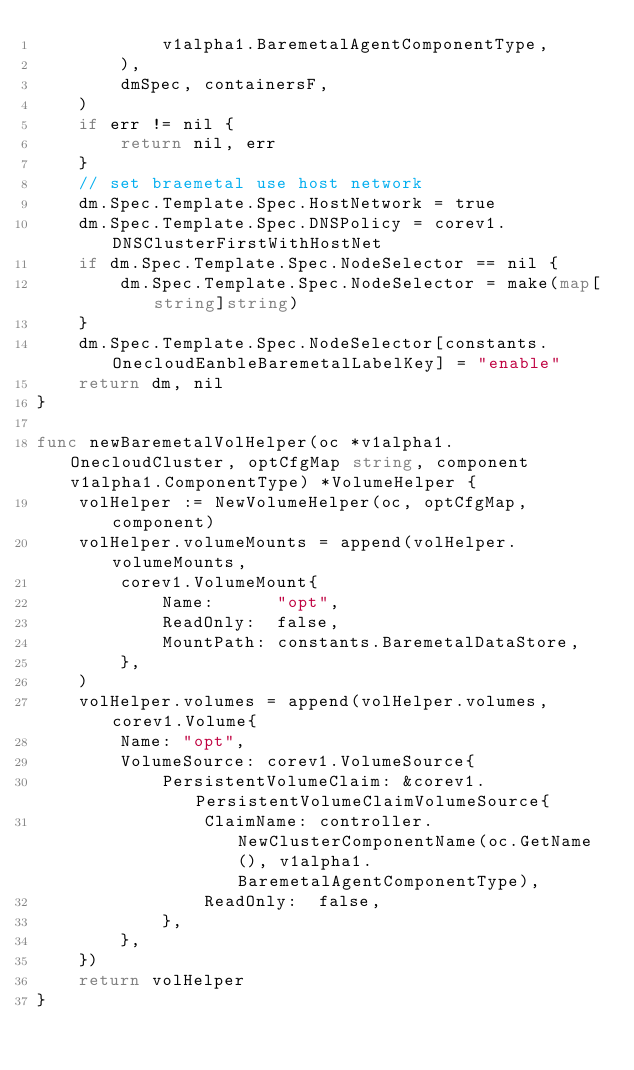<code> <loc_0><loc_0><loc_500><loc_500><_Go_>			v1alpha1.BaremetalAgentComponentType,
		),
		dmSpec, containersF,
	)
	if err != nil {
		return nil, err
	}
	// set braemetal use host network
	dm.Spec.Template.Spec.HostNetwork = true
	dm.Spec.Template.Spec.DNSPolicy = corev1.DNSClusterFirstWithHostNet
	if dm.Spec.Template.Spec.NodeSelector == nil {
		dm.Spec.Template.Spec.NodeSelector = make(map[string]string)
	}
	dm.Spec.Template.Spec.NodeSelector[constants.OnecloudEanbleBaremetalLabelKey] = "enable"
	return dm, nil
}

func newBaremetalVolHelper(oc *v1alpha1.OnecloudCluster, optCfgMap string, component v1alpha1.ComponentType) *VolumeHelper {
	volHelper := NewVolumeHelper(oc, optCfgMap, component)
	volHelper.volumeMounts = append(volHelper.volumeMounts,
		corev1.VolumeMount{
			Name:      "opt",
			ReadOnly:  false,
			MountPath: constants.BaremetalDataStore,
		},
	)
	volHelper.volumes = append(volHelper.volumes, corev1.Volume{
		Name: "opt",
		VolumeSource: corev1.VolumeSource{
			PersistentVolumeClaim: &corev1.PersistentVolumeClaimVolumeSource{
				ClaimName: controller.NewClusterComponentName(oc.GetName(), v1alpha1.BaremetalAgentComponentType),
				ReadOnly:  false,
			},
		},
	})
	return volHelper
}
</code> 